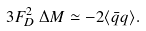Convert formula to latex. <formula><loc_0><loc_0><loc_500><loc_500>3 F _ { D } ^ { 2 } \, \Delta M \simeq - 2 \langle \bar { q } q \rangle .</formula> 